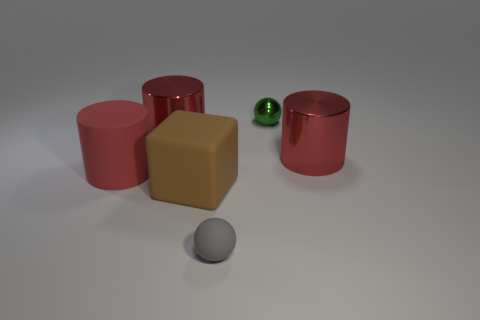What color is the cylinder that is made of the same material as the brown block?
Keep it short and to the point. Red. Do the red metallic thing to the right of the gray thing and the small shiny thing right of the large brown matte thing have the same shape?
Offer a very short reply. No. What number of shiny objects are either gray cylinders or large red cylinders?
Your answer should be compact. 2. Is there anything else that has the same shape as the big brown rubber object?
Your response must be concise. No. There is a red cylinder to the right of the matte cube; what material is it?
Ensure brevity in your answer.  Metal. Do the tiny sphere in front of the rubber cylinder and the green sphere have the same material?
Provide a succinct answer. No. What number of things are either red cylinders or big cylinders on the left side of the green shiny sphere?
Keep it short and to the point. 3. What is the size of the other matte object that is the same shape as the small green thing?
Give a very brief answer. Small. There is a tiny matte sphere; are there any small rubber objects in front of it?
Make the answer very short. No. There is a metal cylinder that is on the left side of the big brown object; is it the same color as the large cylinder to the right of the gray thing?
Your answer should be compact. Yes. 